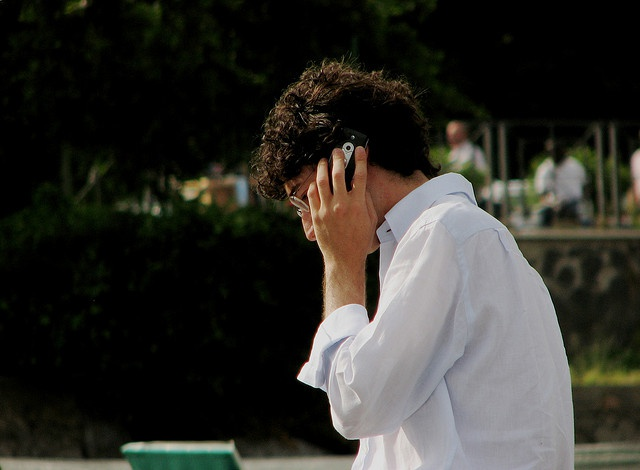Describe the objects in this image and their specific colors. I can see people in gray, darkgray, black, lightgray, and maroon tones, people in gray, black, and darkgray tones, cell phone in gray, black, darkgray, and maroon tones, and people in gray, darkgray, and maroon tones in this image. 